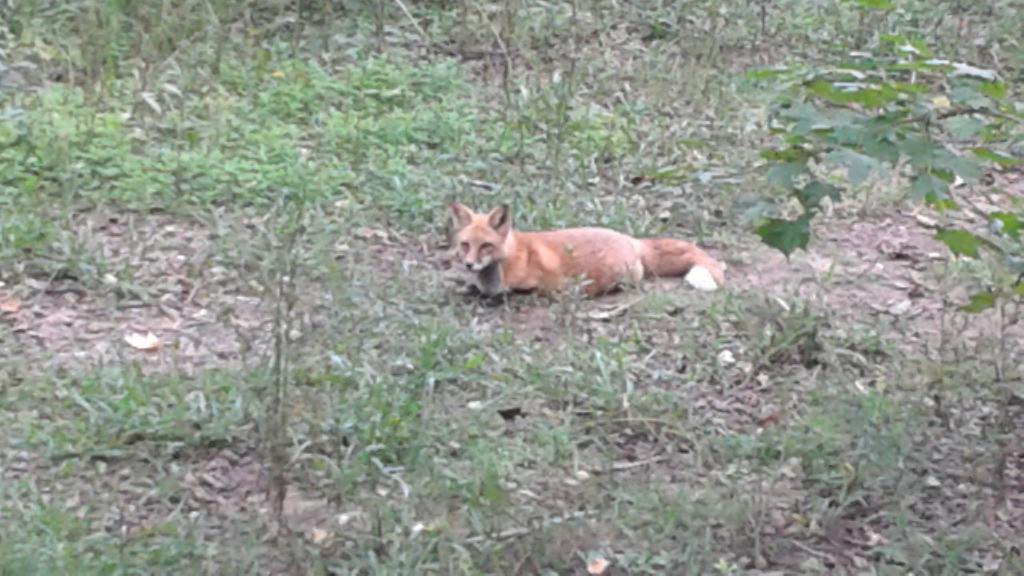In one or two sentences, can you explain what this image depicts? In this picture we can see a fox laying here, at the bottom we can see some leaves and grass. 